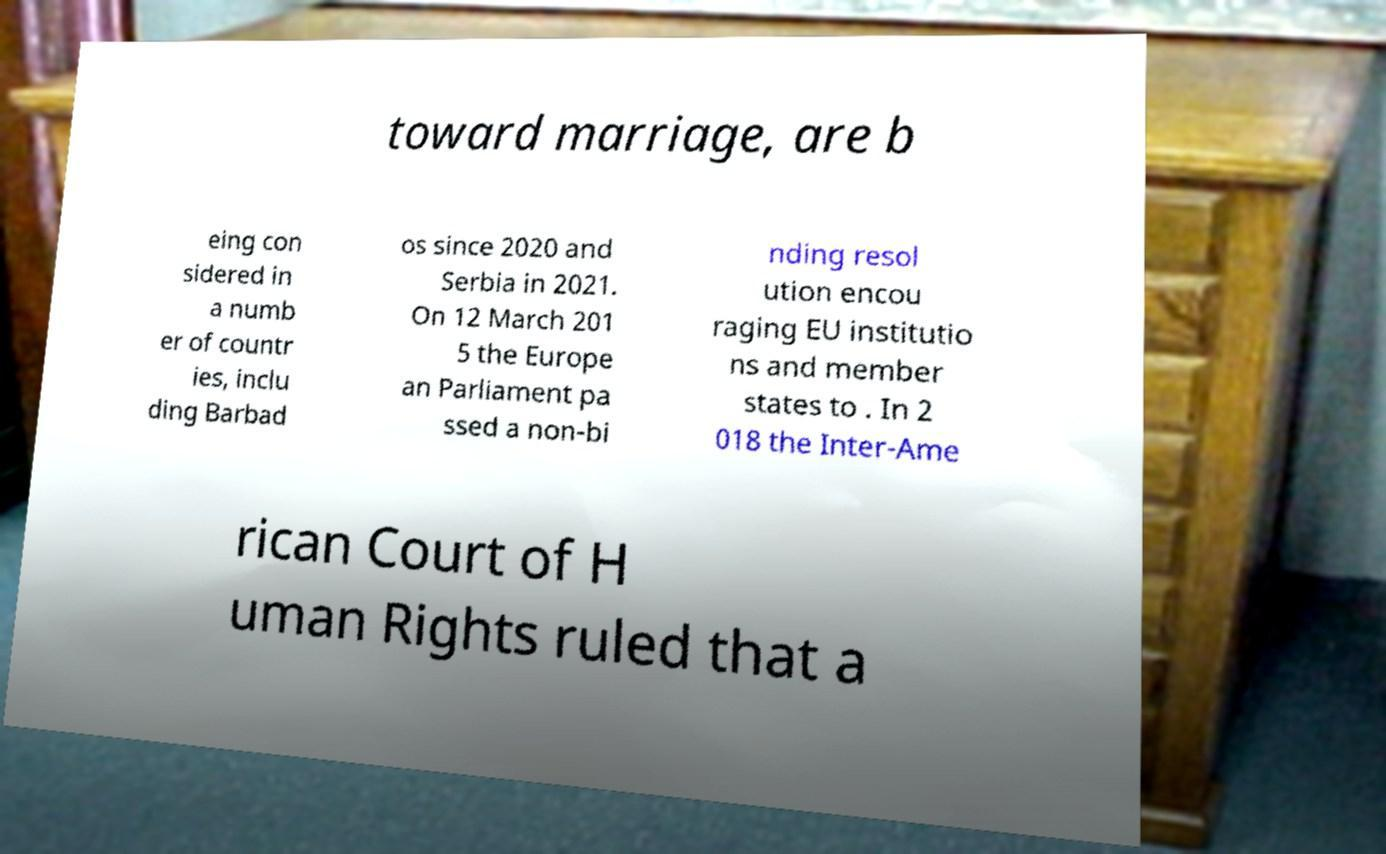Could you assist in decoding the text presented in this image and type it out clearly? toward marriage, are b eing con sidered in a numb er of countr ies, inclu ding Barbad os since 2020 and Serbia in 2021. On 12 March 201 5 the Europe an Parliament pa ssed a non-bi nding resol ution encou raging EU institutio ns and member states to . In 2 018 the Inter-Ame rican Court of H uman Rights ruled that a 